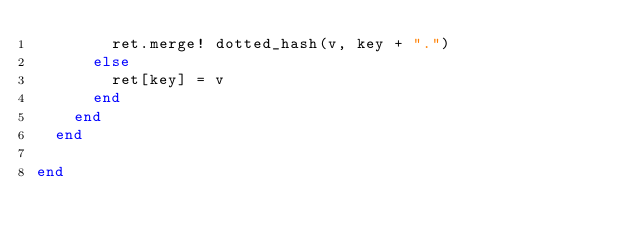<code> <loc_0><loc_0><loc_500><loc_500><_Ruby_>        ret.merge! dotted_hash(v, key + ".")
      else
        ret[key] = v
      end
    end
  end

end
</code> 